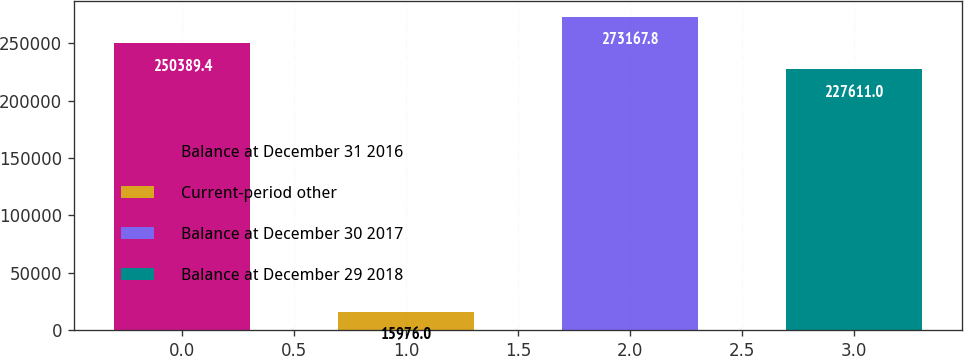Convert chart. <chart><loc_0><loc_0><loc_500><loc_500><bar_chart><fcel>Balance at December 31 2016<fcel>Current-period other<fcel>Balance at December 30 2017<fcel>Balance at December 29 2018<nl><fcel>250389<fcel>15976<fcel>273168<fcel>227611<nl></chart> 